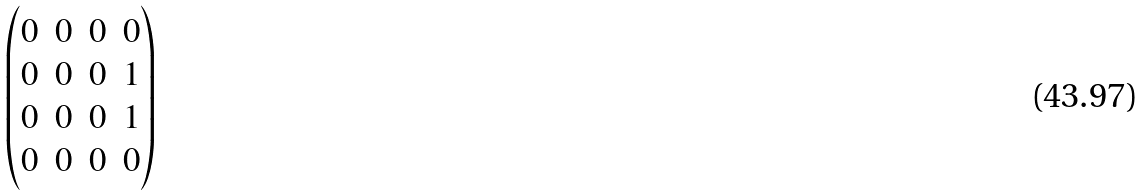<formula> <loc_0><loc_0><loc_500><loc_500>\begin{pmatrix} 0 & 0 & 0 & 0 \\ 0 & 0 & 0 & 1 \\ 0 & 0 & 0 & 1 \\ 0 & 0 & 0 & 0 \end{pmatrix}</formula> 